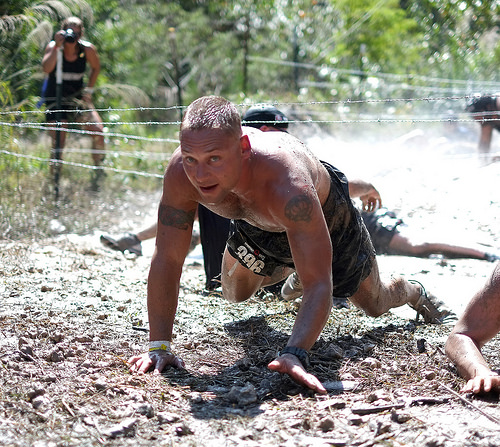<image>
Is the man on the camera? No. The man is not positioned on the camera. They may be near each other, but the man is not supported by or resting on top of the camera. Is the camera in front of the man? No. The camera is not in front of the man. The spatial positioning shows a different relationship between these objects. 